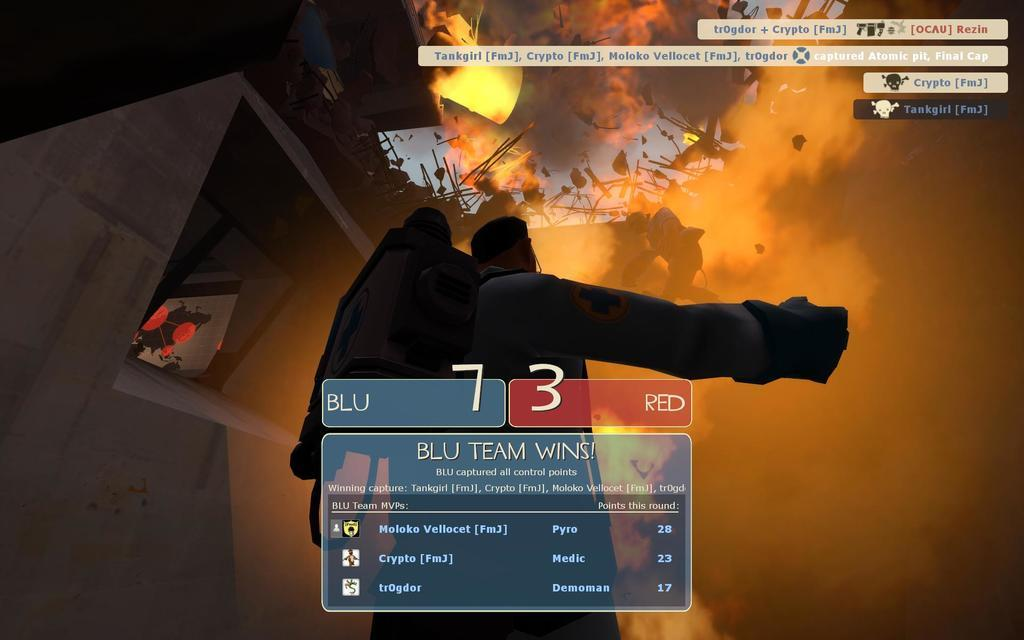<image>
Share a concise interpretation of the image provided. Score from a video game that says 7-3. 